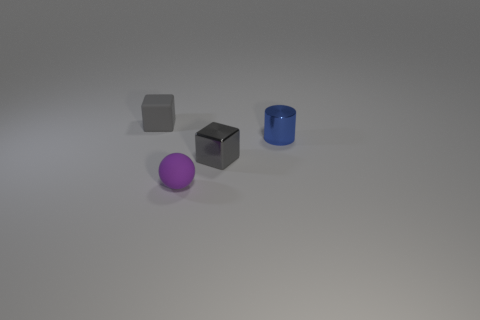Add 4 big yellow blocks. How many objects exist? 8 Subtract all spheres. How many objects are left? 3 Add 2 small gray cubes. How many small gray cubes exist? 4 Subtract 0 cyan balls. How many objects are left? 4 Subtract all metallic blocks. Subtract all shiny cylinders. How many objects are left? 2 Add 4 tiny things. How many tiny things are left? 8 